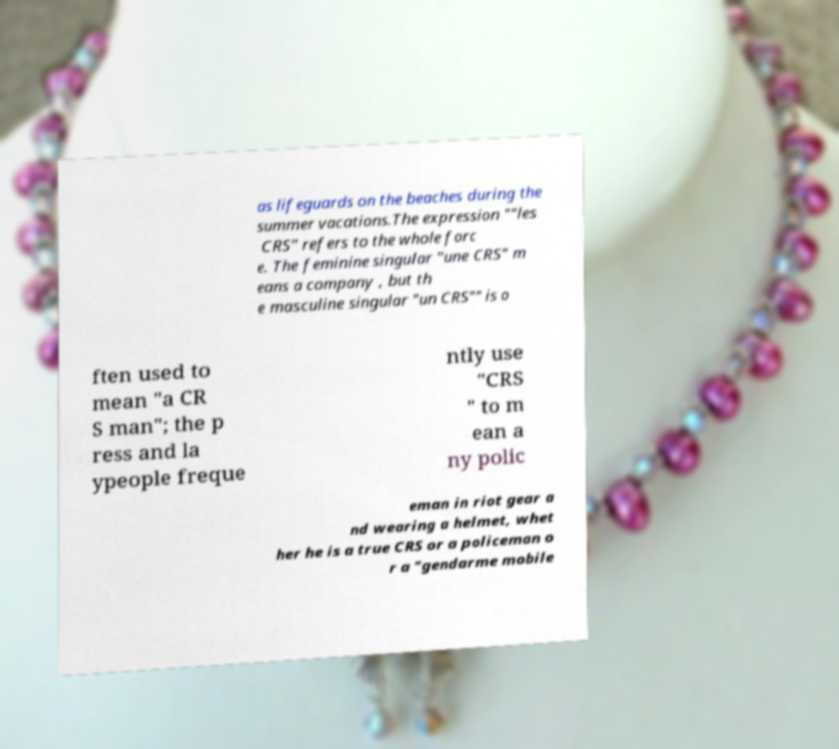Could you extract and type out the text from this image? as lifeguards on the beaches during the summer vacations.The expression ""les CRS" refers to the whole forc e. The feminine singular "une CRS" m eans a company , but th e masculine singular "un CRS"" is o ften used to mean "a CR S man"; the p ress and la ypeople freque ntly use "CRS " to m ean a ny polic eman in riot gear a nd wearing a helmet, whet her he is a true CRS or a policeman o r a "gendarme mobile 